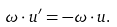<formula> <loc_0><loc_0><loc_500><loc_500>\omega \cdot u ^ { \prime } = - \omega \cdot u .</formula> 